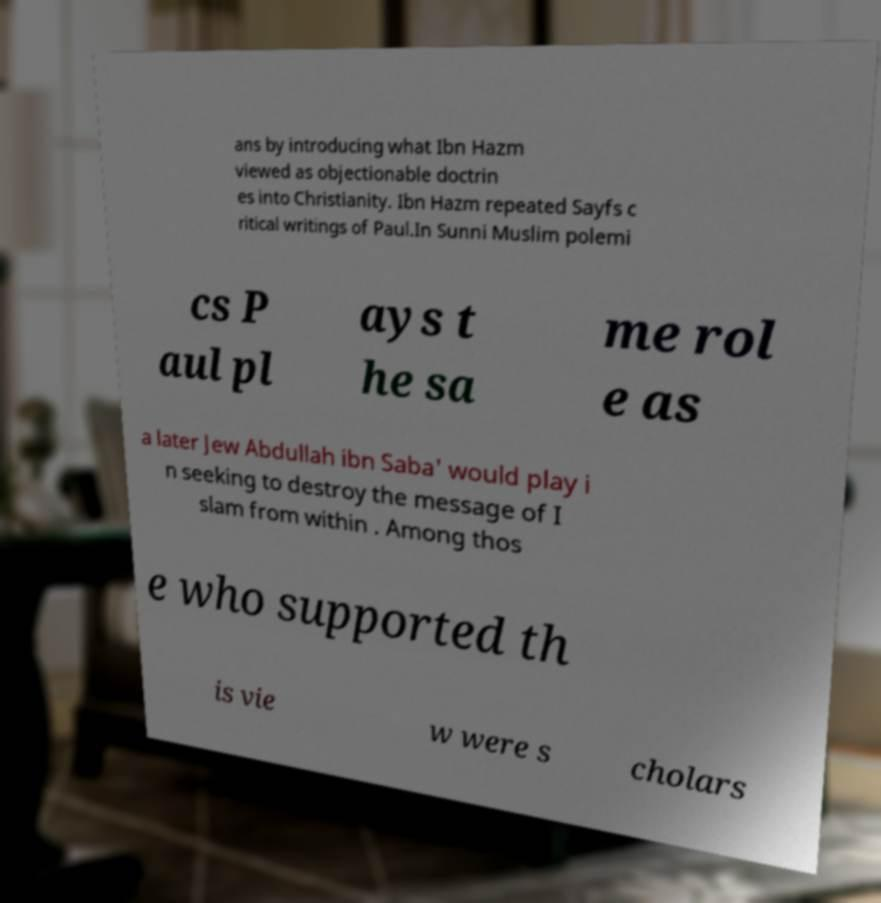Can you accurately transcribe the text from the provided image for me? ans by introducing what Ibn Hazm viewed as objectionable doctrin es into Christianity. Ibn Hazm repeated Sayfs c ritical writings of Paul.In Sunni Muslim polemi cs P aul pl ays t he sa me rol e as a later Jew Abdullah ibn Saba' would play i n seeking to destroy the message of I slam from within . Among thos e who supported th is vie w were s cholars 